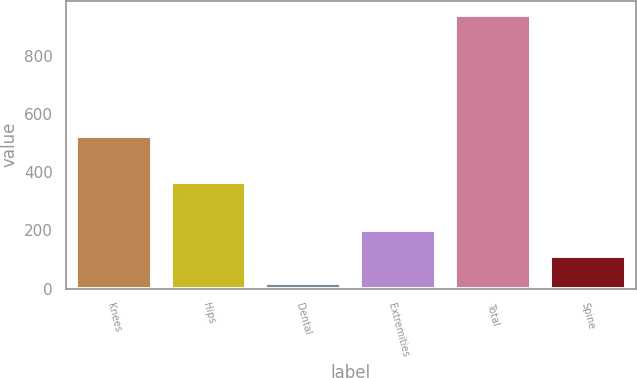Convert chart. <chart><loc_0><loc_0><loc_500><loc_500><bar_chart><fcel>Knees<fcel>Hips<fcel>Dental<fcel>Extremities<fcel>Total<fcel>Spine<nl><fcel>523.6<fcel>365.6<fcel>18.2<fcel>202.84<fcel>941.4<fcel>110.52<nl></chart> 